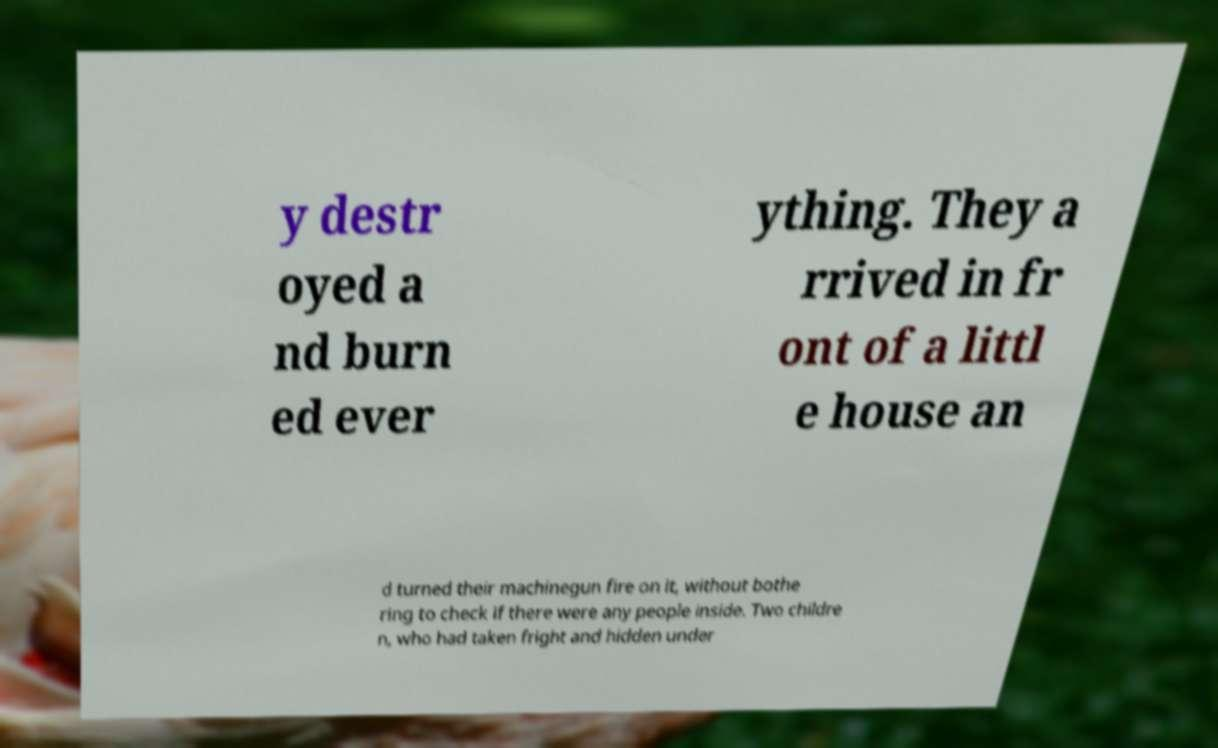Please read and relay the text visible in this image. What does it say? y destr oyed a nd burn ed ever ything. They a rrived in fr ont of a littl e house an d turned their machinegun fire on it, without bothe ring to check if there were any people inside. Two childre n, who had taken fright and hidden under 